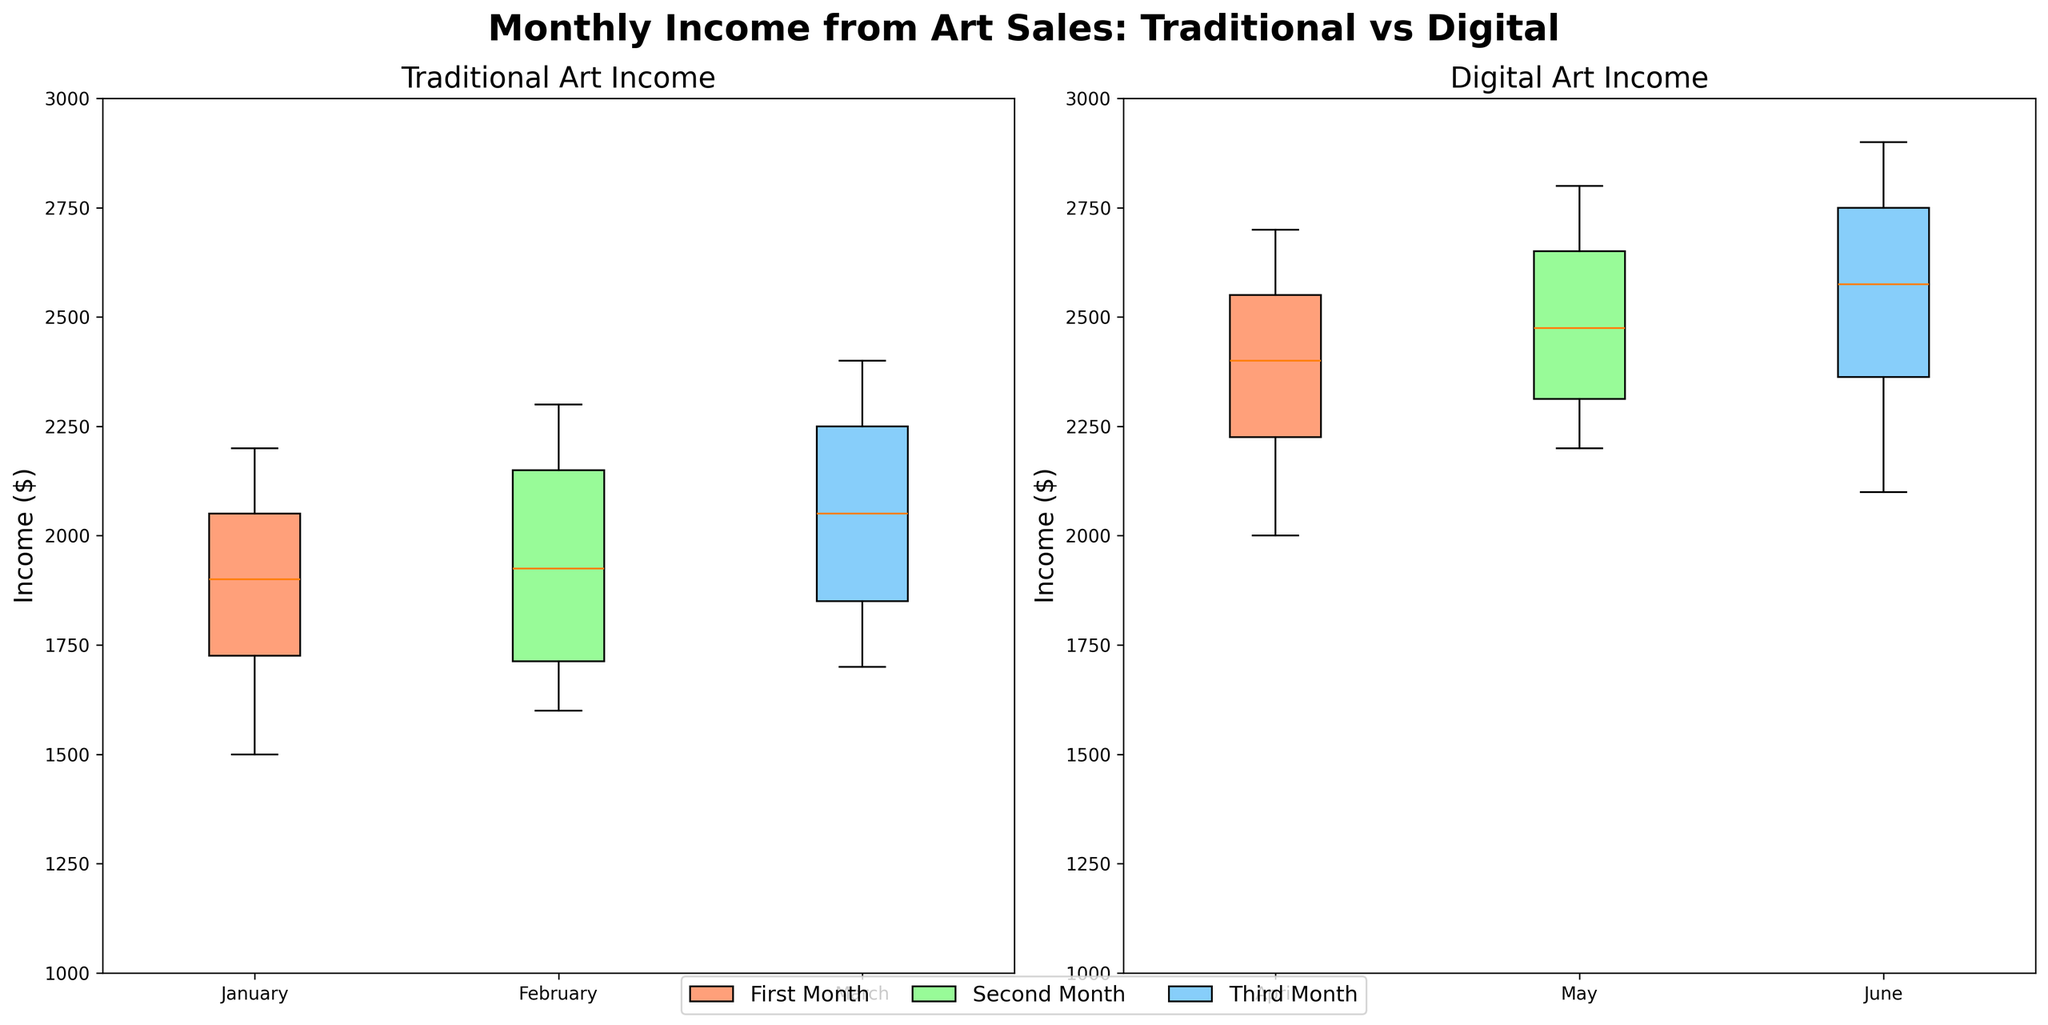Which month shows the highest median income for traditional art? Identify the median value for each month in the traditional art subplot. March has the highest median income among the three.
Answer: March How do the income distributions between January and February for traditional art compare? Look at the box plots for January and February. January has a slightly lower median and a wider interquartile range (IQR) compared to February, which indicates more variability.
Answer: January has more variability and a slightly lower median What is the difference in median income between March for traditional art and April for digital art? Identify the median values for March (Traditional) and April (Digital). Subtract March's median from April's median. March's median is around 2000, and April's median is roughly 2500.
Answer: 500 Are the income ranges (whiskers) in each month for digital art wider or narrower compared to traditional art? Compare the length of the whiskers in digital art months to those in traditional art months. Traditional art months have relatively shorter whiskers, indicating a narrower range, whereas digital art months show longer whiskers, indicating a wider income range.
Answer: Wider for digital art Which medium shows more consistency in monthly income, Traditional or Digital, based on IQR (Interquartile Range)? Compare the IQR (the box length) of each month in both subplots. Traditional art months have slightly smaller IQRs compared to digital art months, indicating more consistency.
Answer: Traditional How has the average income changed from March in traditional art to May in digital art? Calculate the average income for March (Traditional) and May (Digital). March has an average around 2050, and May has an average near 2500. The difference is approximately 450.
Answer: Increased by about 450 Which month shows the smallest income variability for traditional art? For the traditional art subplot, identify the month with the smallest IQR (the box length). February has the smallest IQR, indicating the least variability.
Answer: February What trend do you observe in the median income from traditional to digital art over the three months? Track the median income from January to March (Traditional) and April to June (Digital). The median income trend shows an upward shift when transitioning to digital art.
Answer: Upward trend By how much does the median income increase from the last traditional art month (March) to the first digital art month (April)? Identify the median income for March and April. Subtract the median of March from the median of April. March's median is around 2000, and April's median is about 2500.
Answer: 500 What is the range of incomes for digital art in April? Determine the minimum and maximum values (whiskers) for April in the digital art subplot. The range is from roughly 2000 to 2700.
Answer: 700 